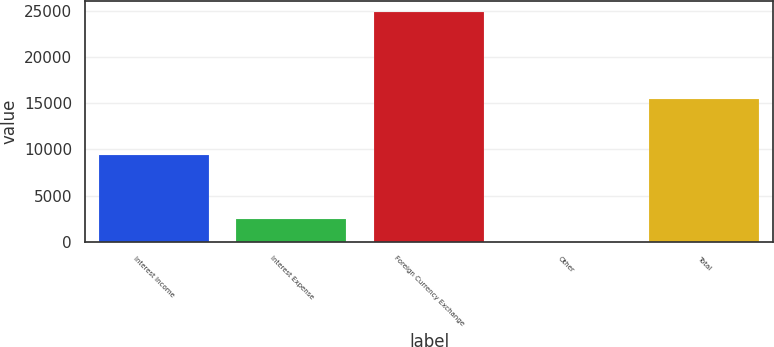<chart> <loc_0><loc_0><loc_500><loc_500><bar_chart><fcel>Interest Income<fcel>Interest Expense<fcel>Foreign Currency Exchange<fcel>Other<fcel>Total<nl><fcel>9419<fcel>2499<fcel>24819<fcel>19<fcel>15457<nl></chart> 